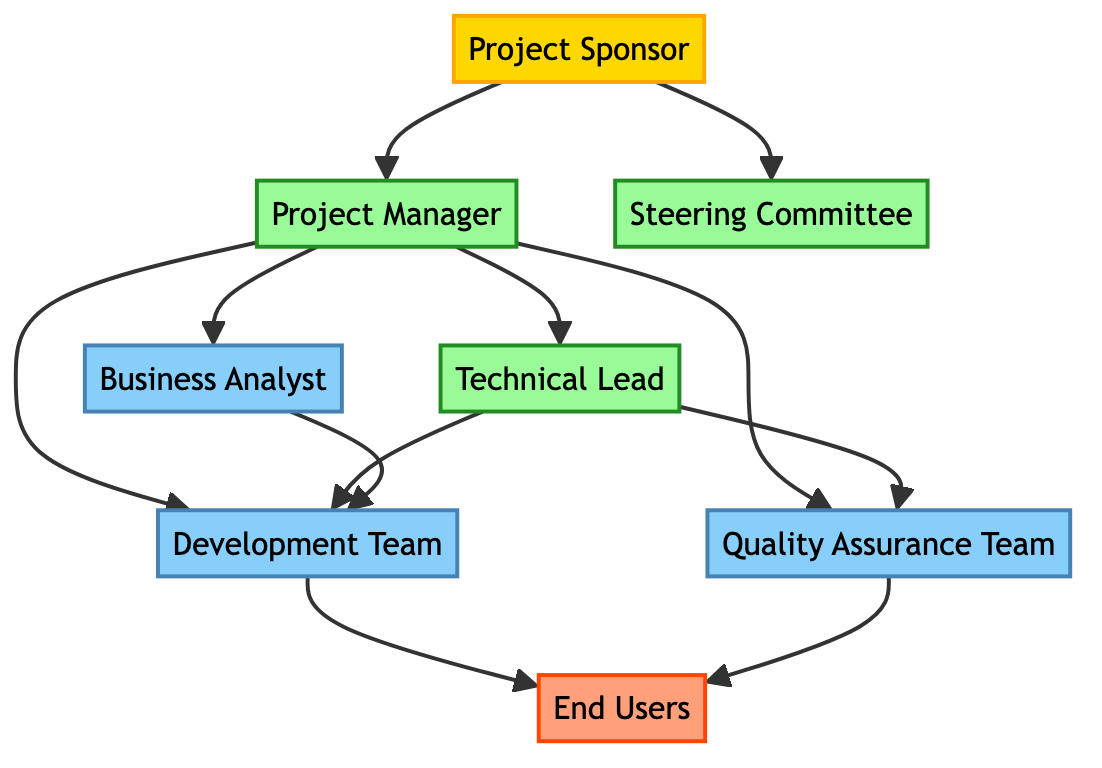What is the highest level stakeholder in the diagram? The highest level stakeholder is represented by the node at the top of the diagram, which is the Project Sponsor.
Answer: Project Sponsor How many middle-level stakeholders are there? There are three middle-level stakeholders represented in the diagram: Project Manager, Steering Committee, and Technical Lead.
Answer: 3 Which stakeholder is responsible for the technical direction of the project? By examining the connections and descriptions, the Technical Lead is identified as the stakeholder responsible for the technical direction and quality of the project's outputs.
Answer: Technical Lead Who do the Development Team report to directly? The arrows indicate that the Development Team reports directly to the Project Manager and the Technical Lead, reflecting their supervisory roles in the diagram.
Answer: Project Manager, Technical Lead What is the connection between the Business Analyst and the Development Team? The diagram shows an arrow from the Business Analyst to the Development Team, indicating that the Business Analyst provides input or requirements that the Development Team implements.
Answer: Input/Requirements Which stakeholder group has the most direct collaborations with the End Users? The diagram shows that both the Development Team and the Quality Assurance Team have direct output connections to the End Users, indicating collaborations with them.
Answer: Development Team, Quality Assurance Team How many edges are there in the diagram? By counting all the directed connections (arrows) between the nodes, there are a total of 10 edges connecting the stakeholders in the diagram.
Answer: 10 What level does the Quality Assurance Team belong to? The node representing the Quality Assurance Team is marked as belonging to the lower level in the diagram, indicating its position.
Answer: Lower Which stakeholder provides financial resources for the project? The description associated with the Project Sponsor indicates that this stakeholder provides the financial resources and support needed for the project.
Answer: Project Sponsor What is the role of End Users in the hierarchical structure? According to the diagram, the End Users are positioned at the bottom level, indicating that they are the final recipients of the project's outputs and provide feedback.
Answer: Feedback 